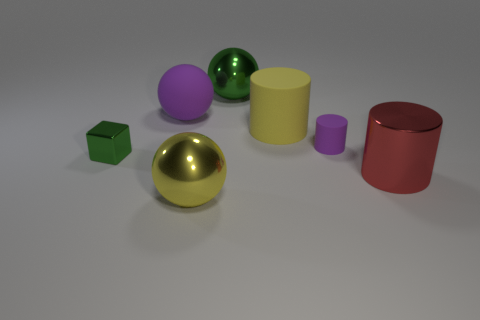Is the small cylinder the same color as the big rubber sphere?
Provide a short and direct response. Yes. There is a green shiny thing that is to the left of the green shiny sphere; is it the same size as the large shiny cylinder?
Provide a succinct answer. No. What is the shape of the yellow thing that is in front of the small object on the left side of the metal ball behind the big purple rubber thing?
Your answer should be very brief. Sphere. How many objects are large yellow cylinders or matte things to the left of the purple rubber cylinder?
Provide a succinct answer. 2. What size is the rubber thing to the right of the big yellow matte cylinder?
Your answer should be compact. Small. What shape is the small object that is the same color as the rubber sphere?
Your answer should be very brief. Cylinder. Are the red cylinder and the green object behind the small green metal cube made of the same material?
Make the answer very short. Yes. What number of big cylinders are in front of the tiny object to the left of the big yellow thing that is in front of the red thing?
Ensure brevity in your answer.  1. How many yellow objects are either large matte things or large metal cylinders?
Offer a very short reply. 1. There is a big object in front of the big metal cylinder; what shape is it?
Ensure brevity in your answer.  Sphere. 